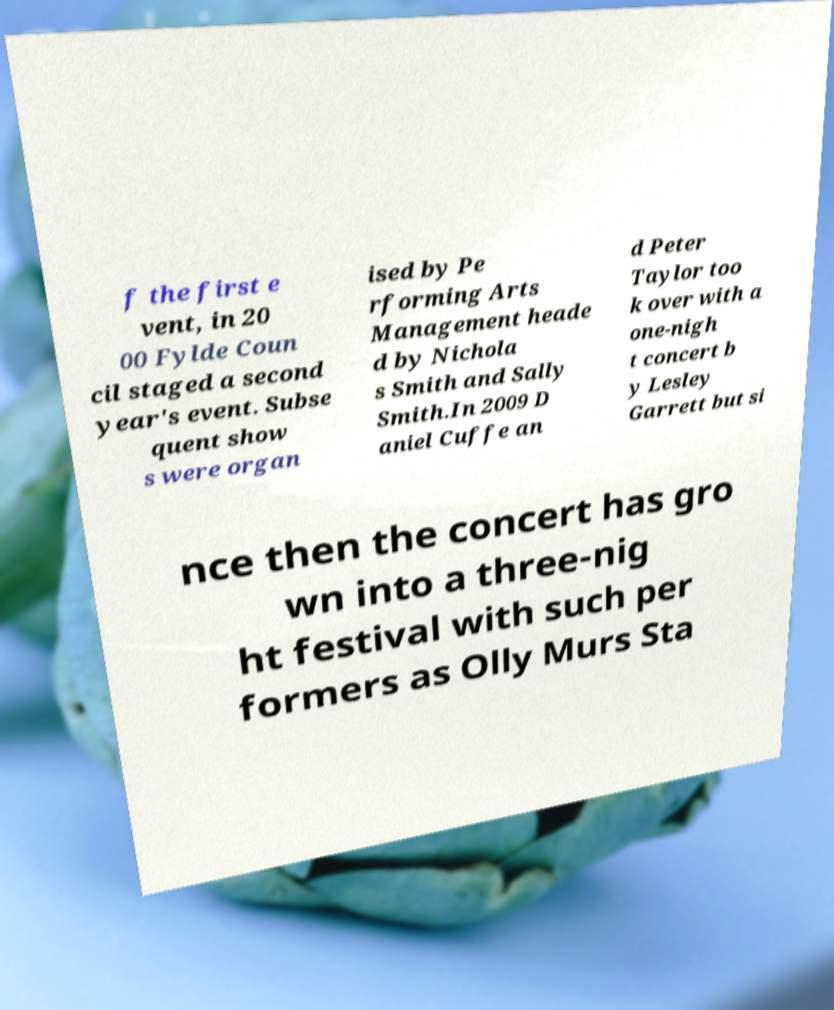There's text embedded in this image that I need extracted. Can you transcribe it verbatim? f the first e vent, in 20 00 Fylde Coun cil staged a second year's event. Subse quent show s were organ ised by Pe rforming Arts Management heade d by Nichola s Smith and Sally Smith.In 2009 D aniel Cuffe an d Peter Taylor too k over with a one-nigh t concert b y Lesley Garrett but si nce then the concert has gro wn into a three-nig ht festival with such per formers as Olly Murs Sta 